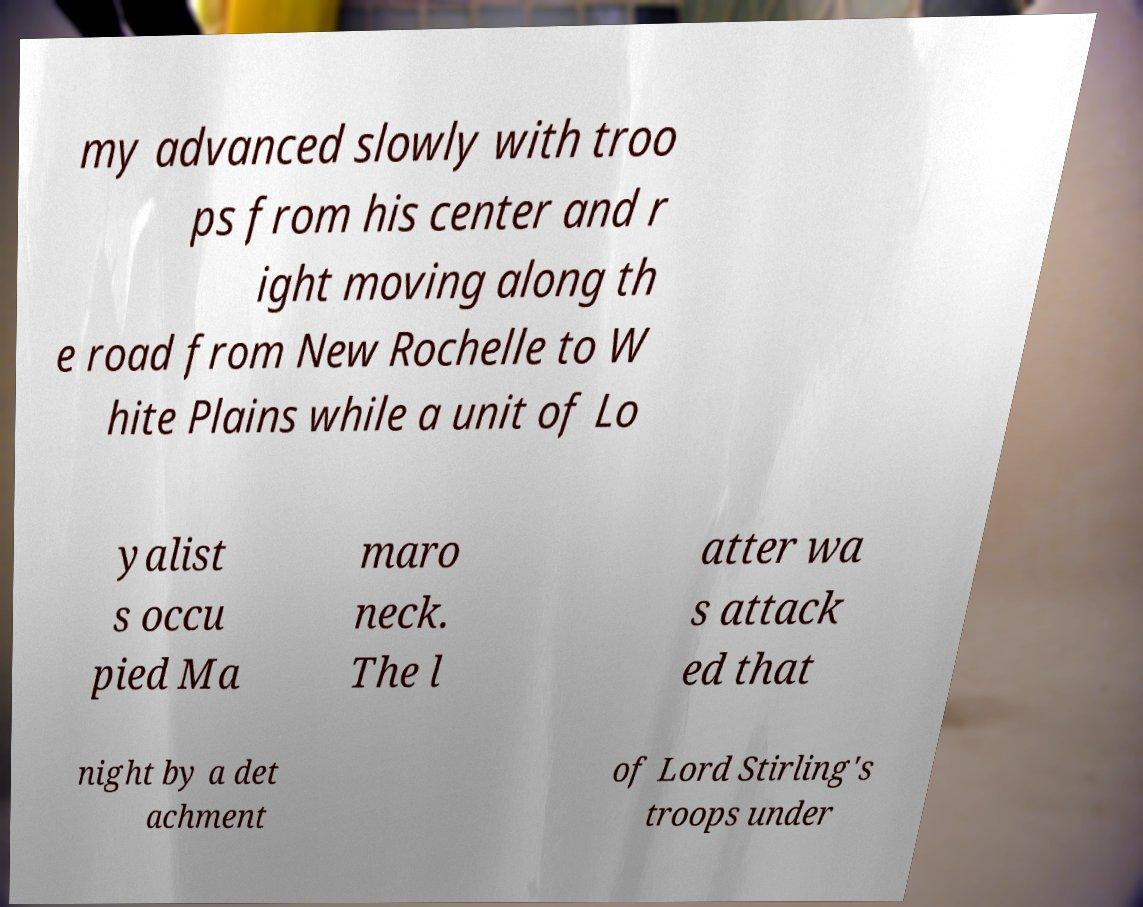Can you accurately transcribe the text from the provided image for me? my advanced slowly with troo ps from his center and r ight moving along th e road from New Rochelle to W hite Plains while a unit of Lo yalist s occu pied Ma maro neck. The l atter wa s attack ed that night by a det achment of Lord Stirling's troops under 